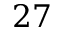Convert formula to latex. <formula><loc_0><loc_0><loc_500><loc_500>2 7</formula> 